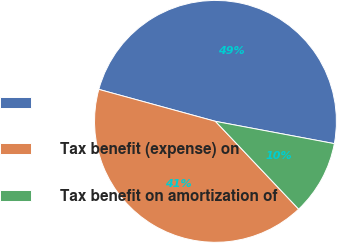<chart> <loc_0><loc_0><loc_500><loc_500><pie_chart><ecel><fcel>Tax benefit (expense) on<fcel>Tax benefit on amortization of<nl><fcel>48.69%<fcel>41.33%<fcel>9.98%<nl></chart> 